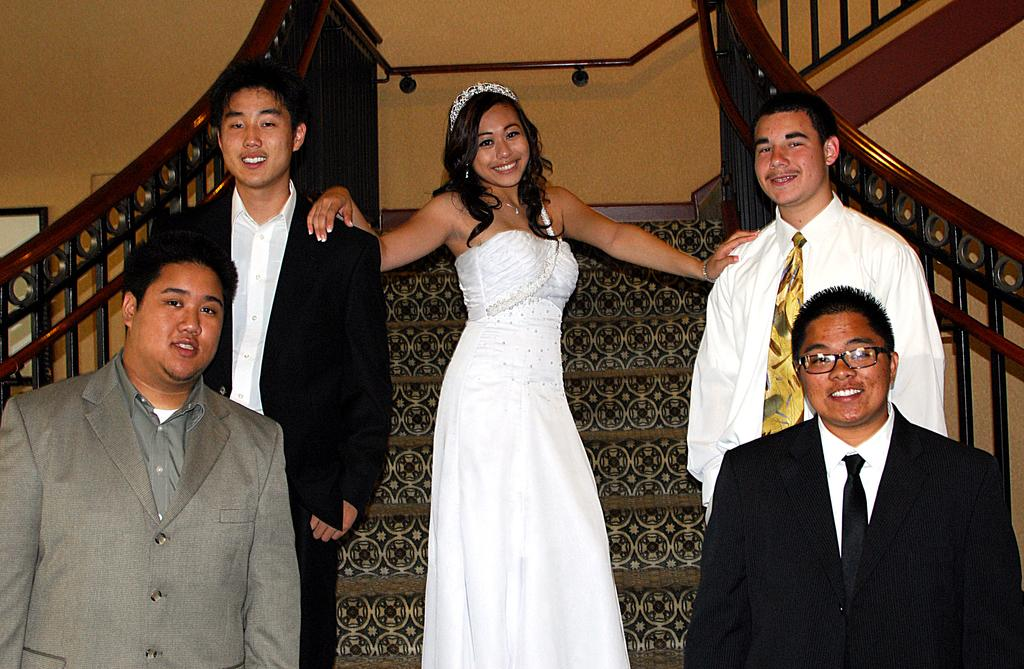Who is the main subject in the center of the image? There is a lady in the center of the image. What is the lady wearing? The lady is wearing a crown and gown. Where is the lady standing? The lady is standing on the steps. How many men are standing on the sides of the lady? There are four men standing on the sides of the lady. What can be seen on the sides of the steps? There are railings on the sides of the steps. What type of birds can be seen flying around the lady in the image? There are no birds visible in the image. What kind of beast is present at the bottom of the steps in the image? There is no beast present in the image; only the lady, men, and railings are visible. 